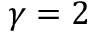<formula> <loc_0><loc_0><loc_500><loc_500>\gamma = 2</formula> 